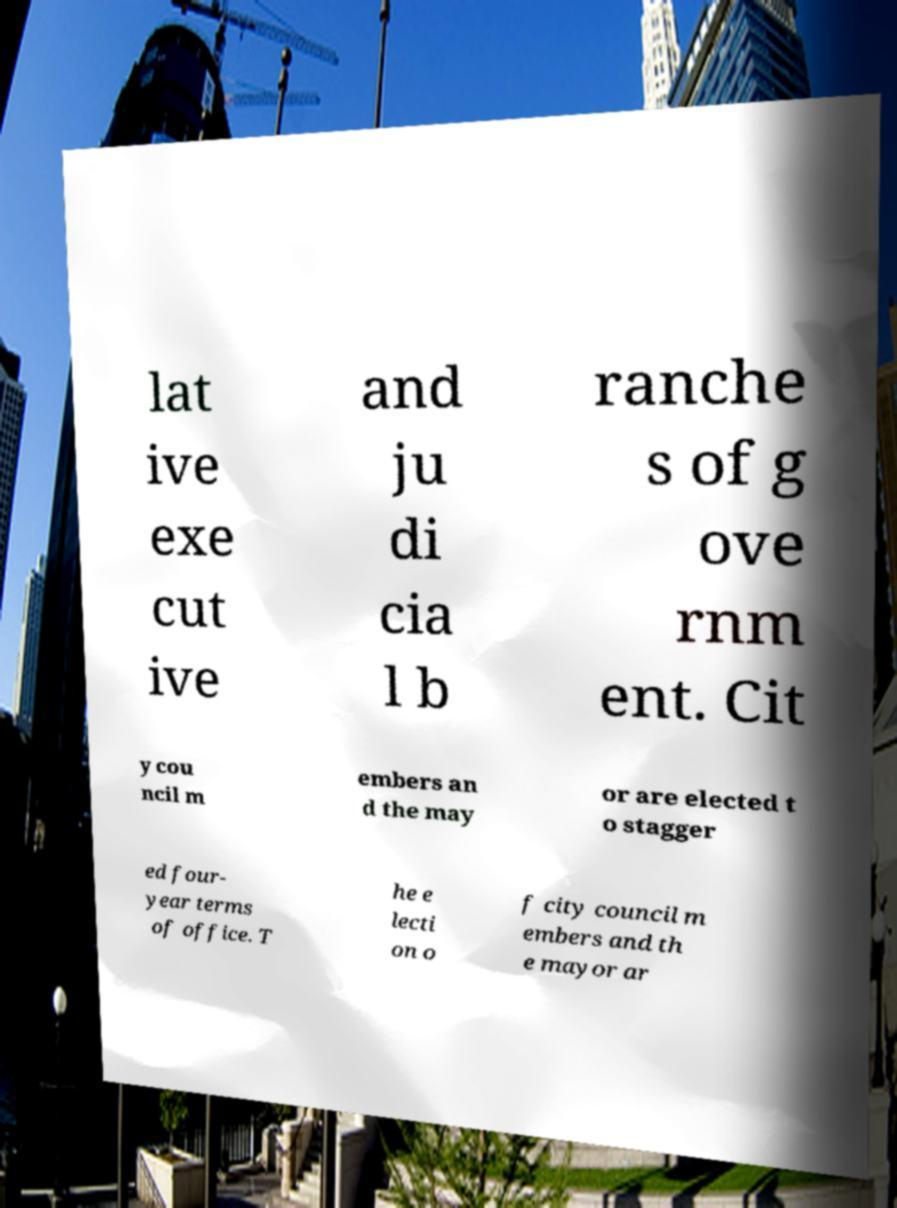There's text embedded in this image that I need extracted. Can you transcribe it verbatim? lat ive exe cut ive and ju di cia l b ranche s of g ove rnm ent. Cit y cou ncil m embers an d the may or are elected t o stagger ed four- year terms of office. T he e lecti on o f city council m embers and th e mayor ar 